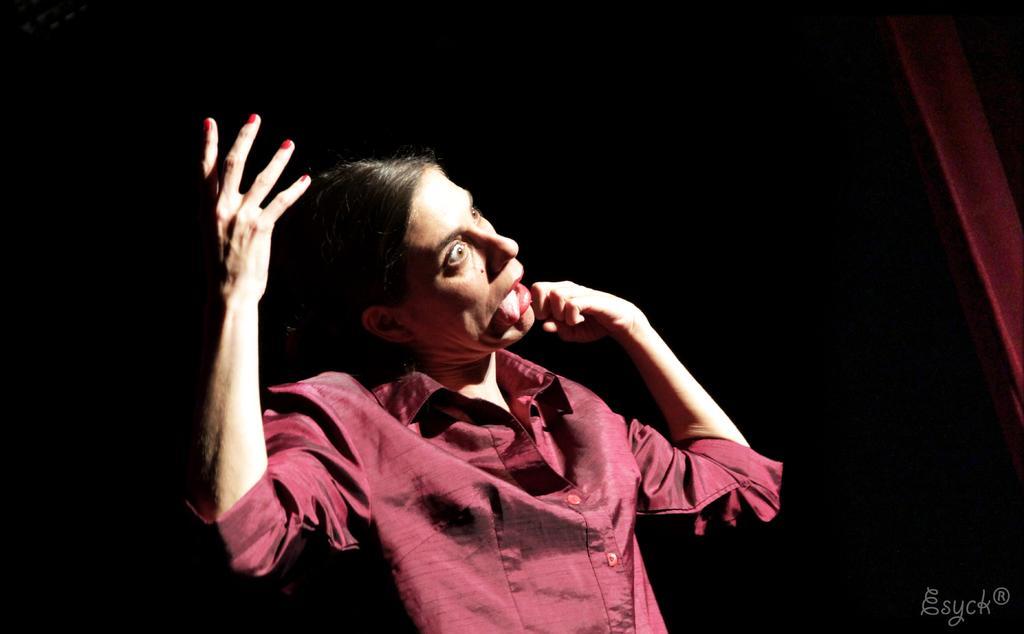Please provide a concise description of this image. In this picture there is a woman who is wearing red shirt. In the back we can see darkness. On the top right we can see red color wall. On the bottom right corner there is a watermark. 